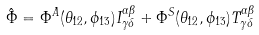Convert formula to latex. <formula><loc_0><loc_0><loc_500><loc_500>\hat { \Phi } = \Phi ^ { A } ( \theta _ { 1 2 } , \phi _ { 1 3 } ) I ^ { \alpha \beta } _ { \gamma \delta } + \Phi ^ { S } ( \theta _ { 1 2 } , \phi _ { 1 3 } ) T ^ { \alpha \beta } _ { \gamma \delta }</formula> 